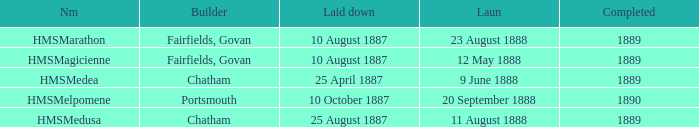Which builder completed after 1889? Portsmouth. 